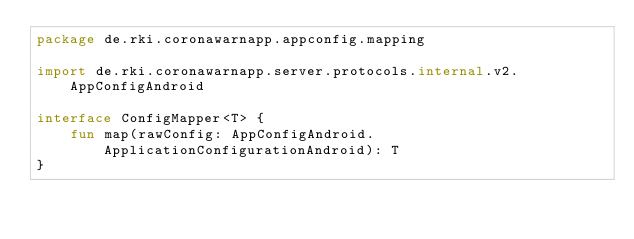<code> <loc_0><loc_0><loc_500><loc_500><_Kotlin_>package de.rki.coronawarnapp.appconfig.mapping

import de.rki.coronawarnapp.server.protocols.internal.v2.AppConfigAndroid

interface ConfigMapper<T> {
    fun map(rawConfig: AppConfigAndroid.ApplicationConfigurationAndroid): T
}
</code> 